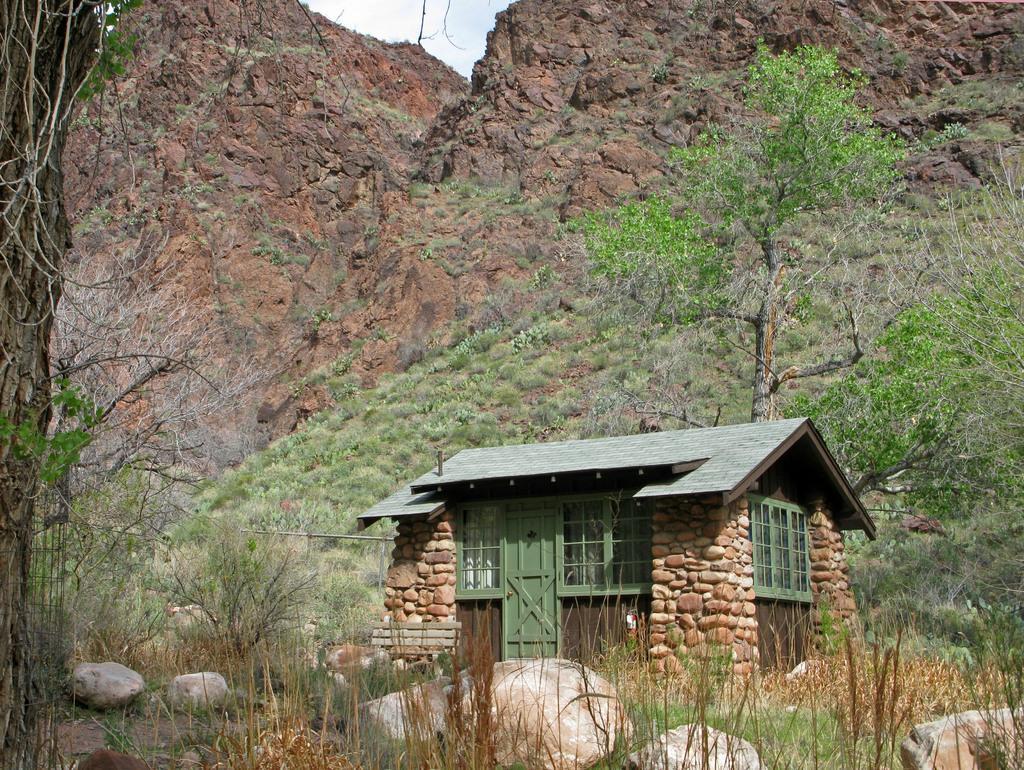Could you give a brief overview of what you see in this image? In this picture we can see a house with door and windows. In the background we can see trees,rock,sky. 